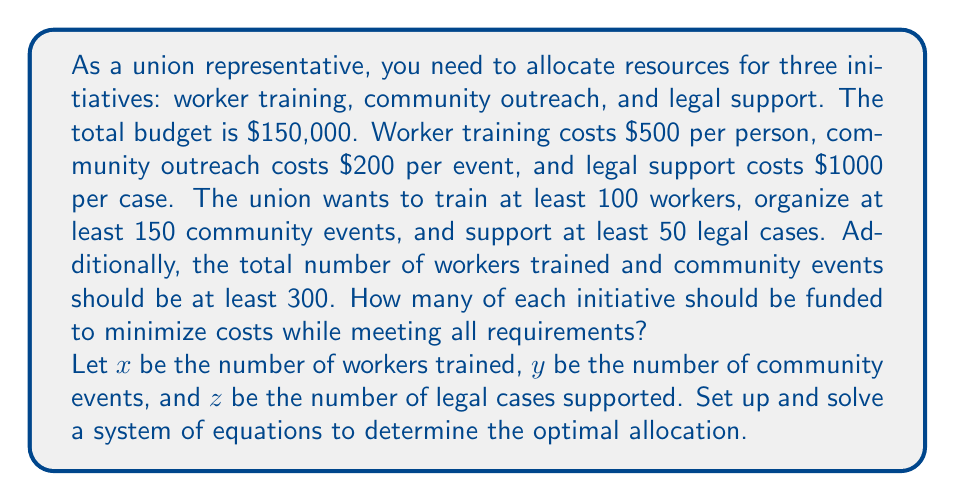Teach me how to tackle this problem. Let's approach this step-by-step:

1) First, let's set up our constraints based on the given information:

   a) Budget constraint: $500x + 200y + 1000z \leq 150000$
   b) Minimum workers trained: $x \geq 100$
   c) Minimum community events: $y \geq 150$
   d) Minimum legal cases: $z \geq 50$
   e) Minimum total of workers and events: $x + y \geq 300$

2) Our objective is to minimize costs while meeting all requirements. This means we want to find the smallest values of $x$, $y$, and $z$ that satisfy all constraints.

3) From constraints (b), (c), and (d), we know that $x \geq 100$, $y \geq 150$, and $z \geq 50$.

4) Constraint (e) states that $x + y \geq 300$. Since we want to minimize costs, we should make this equation equal to 300:

   $x + y = 300$

5) We already know $y \geq 150$, so let's set $y = 150$ to minimize costs. Then:

   $x + 150 = 300$
   $x = 150$

6) Now we have $x = 150$, $y = 150$, and $z = 50$.

7) Let's check if this satisfies the budget constraint:

   $500(150) + 200(150) + 1000(50) = 75000 + 30000 + 50000 = 155000$

   This exceeds our budget of $150,000 by $5,000.

8) To reduce costs, we need to decrease one of our variables. We can't reduce $y$ or $z$ as they're at their minimum values. So we need to reduce $x$.

9) Let's solve for $x$ using the budget constraint:

   $500x + 200(150) + 1000(50) = 150000$
   $500x + 30000 + 50000 = 150000$
   $500x = 70000$
   $x = 140$

Therefore, the optimal allocation is:
$x = 140$ workers trained
$y = 150$ community events
$z = 50$ legal cases supported
Answer: 140 workers trained, 150 community events, 50 legal cases supported 